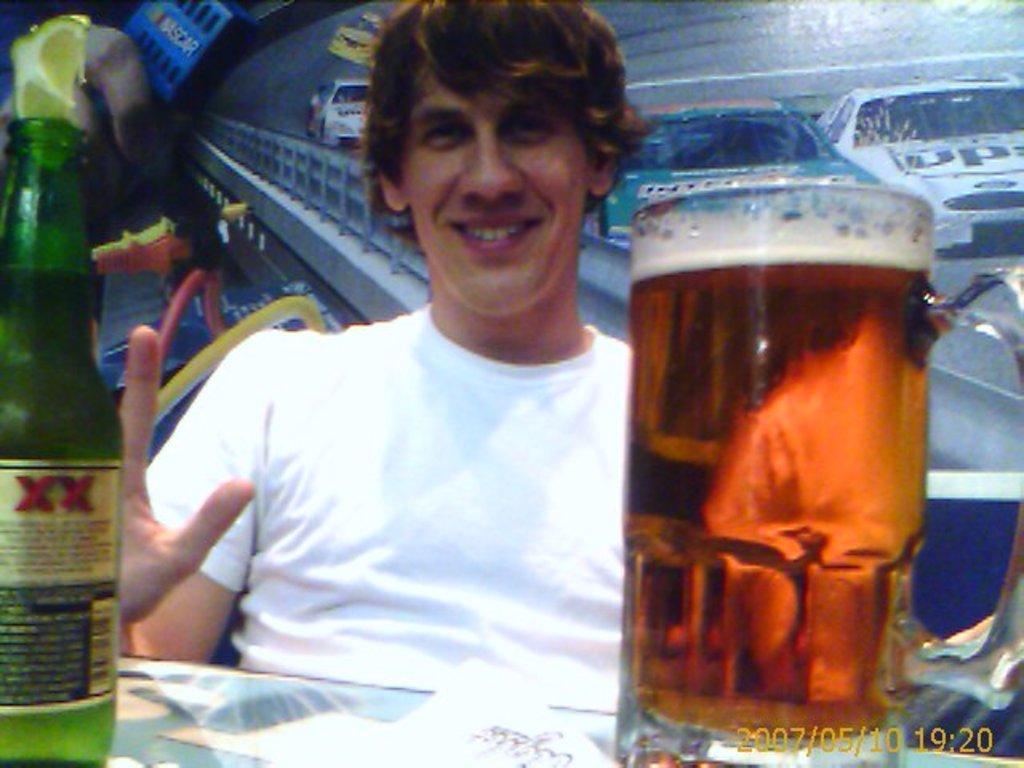How would you summarize this image in a sentence or two? This is a picture of a man in white t shirt sitting on a chair in front of the man there is a table on the table there are glass and a bottle with a lemon. Background of the man is a wall. 